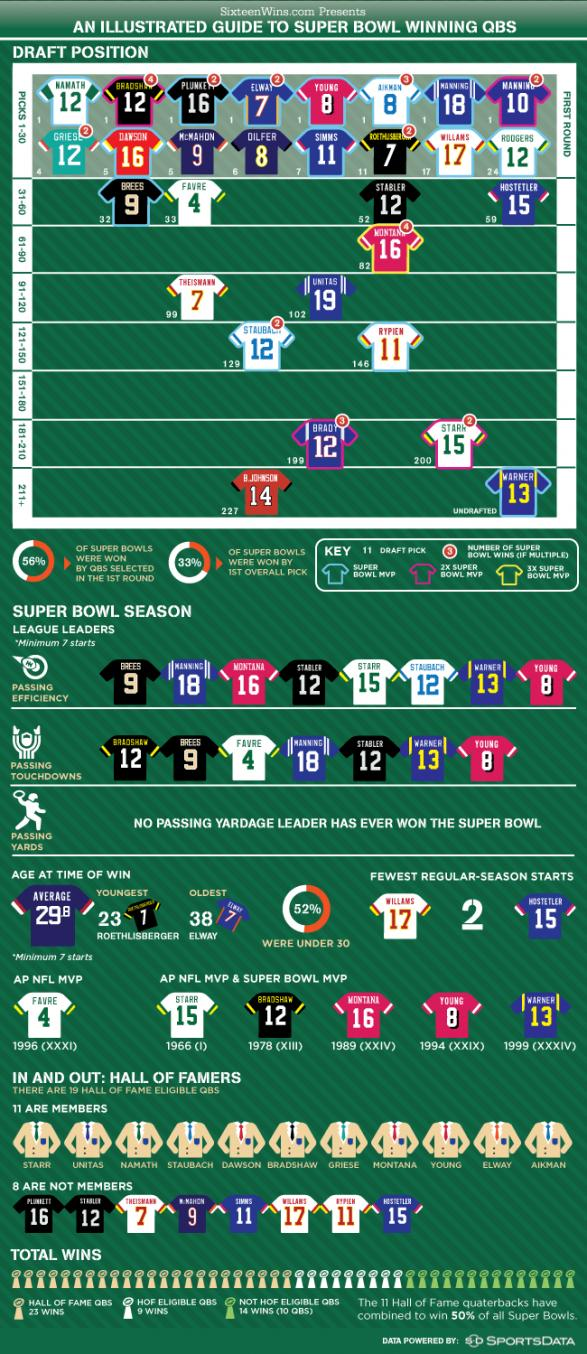Specify some key components in this picture. It is evident that Warner, who is undrafted, is a notable exception. Brady and Stark are included in picks 181-210. Williams and Hostetler have had the fewest regular season starts among all quarterbacks. The average age at the time of a win is 29.8 years. At the time of his win, he was the youngest person to have achieved this age. 